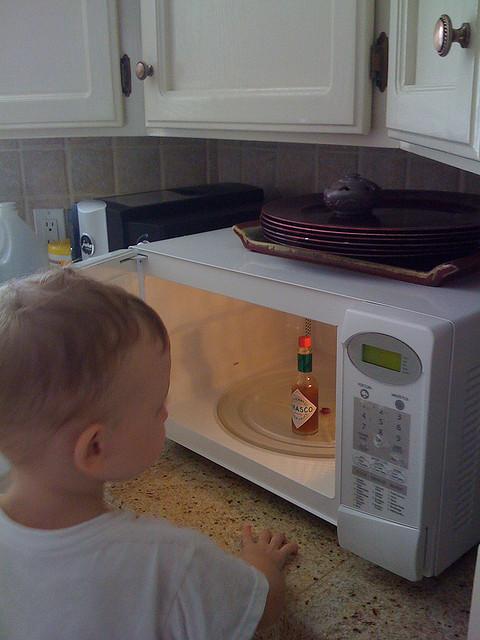What type of hot sauce is this?
Answer briefly. Tabasco. What is inside the microwave?
Answer briefly. Tabasco. Is the baby taller or shorter than the microwave?
Quick response, please. Taller. Is this baby trying to heat up hot sauce?
Concise answer only. Yes. What is the thing on top of the fridge?
Answer briefly. Plates. How many people are in the photo?
Short answer required. 1. Is he cooking pizza?
Give a very brief answer. No. 